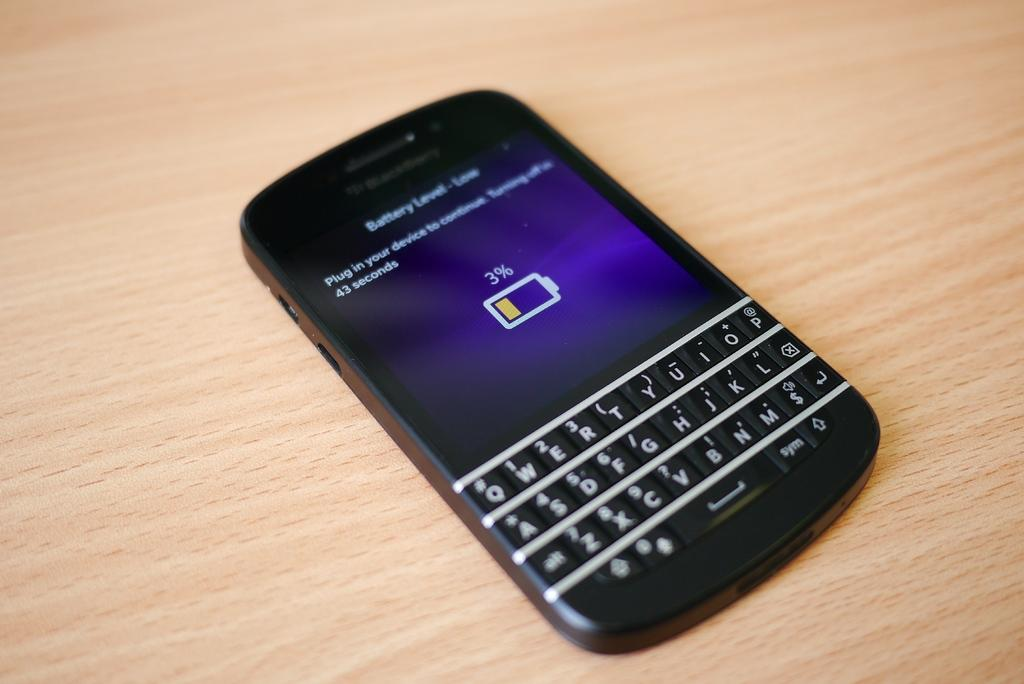<image>
Present a compact description of the photo's key features. A cell phone with only 3% battery sits on a light wood surface. 